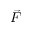<formula> <loc_0><loc_0><loc_500><loc_500>\vec { F }</formula> 